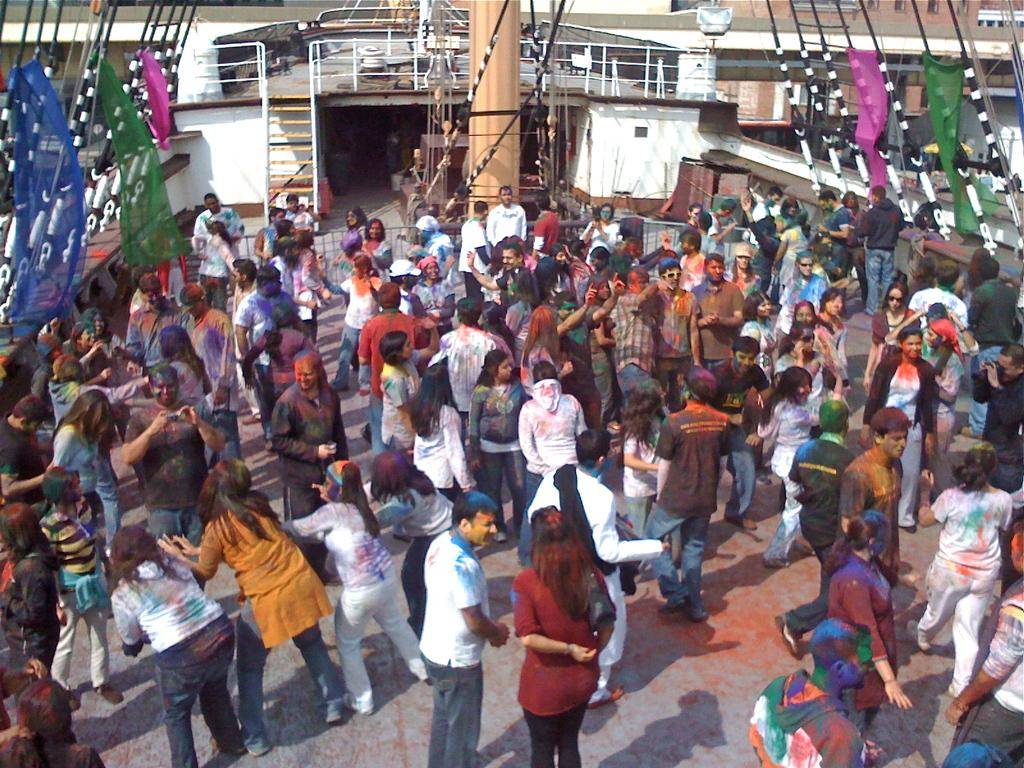How many people are present in the image? There are many people in the image. Where are the people located in the image? The people are in the center of the image. What are the people doing in the image? The people are playing with colors. What can be seen in the center of the image besides the people? There is a pole in the center of the image. What type of memory is being used by the people in the image? There is no mention of memory in the image, so it cannot be determined what type of memory is being used. 